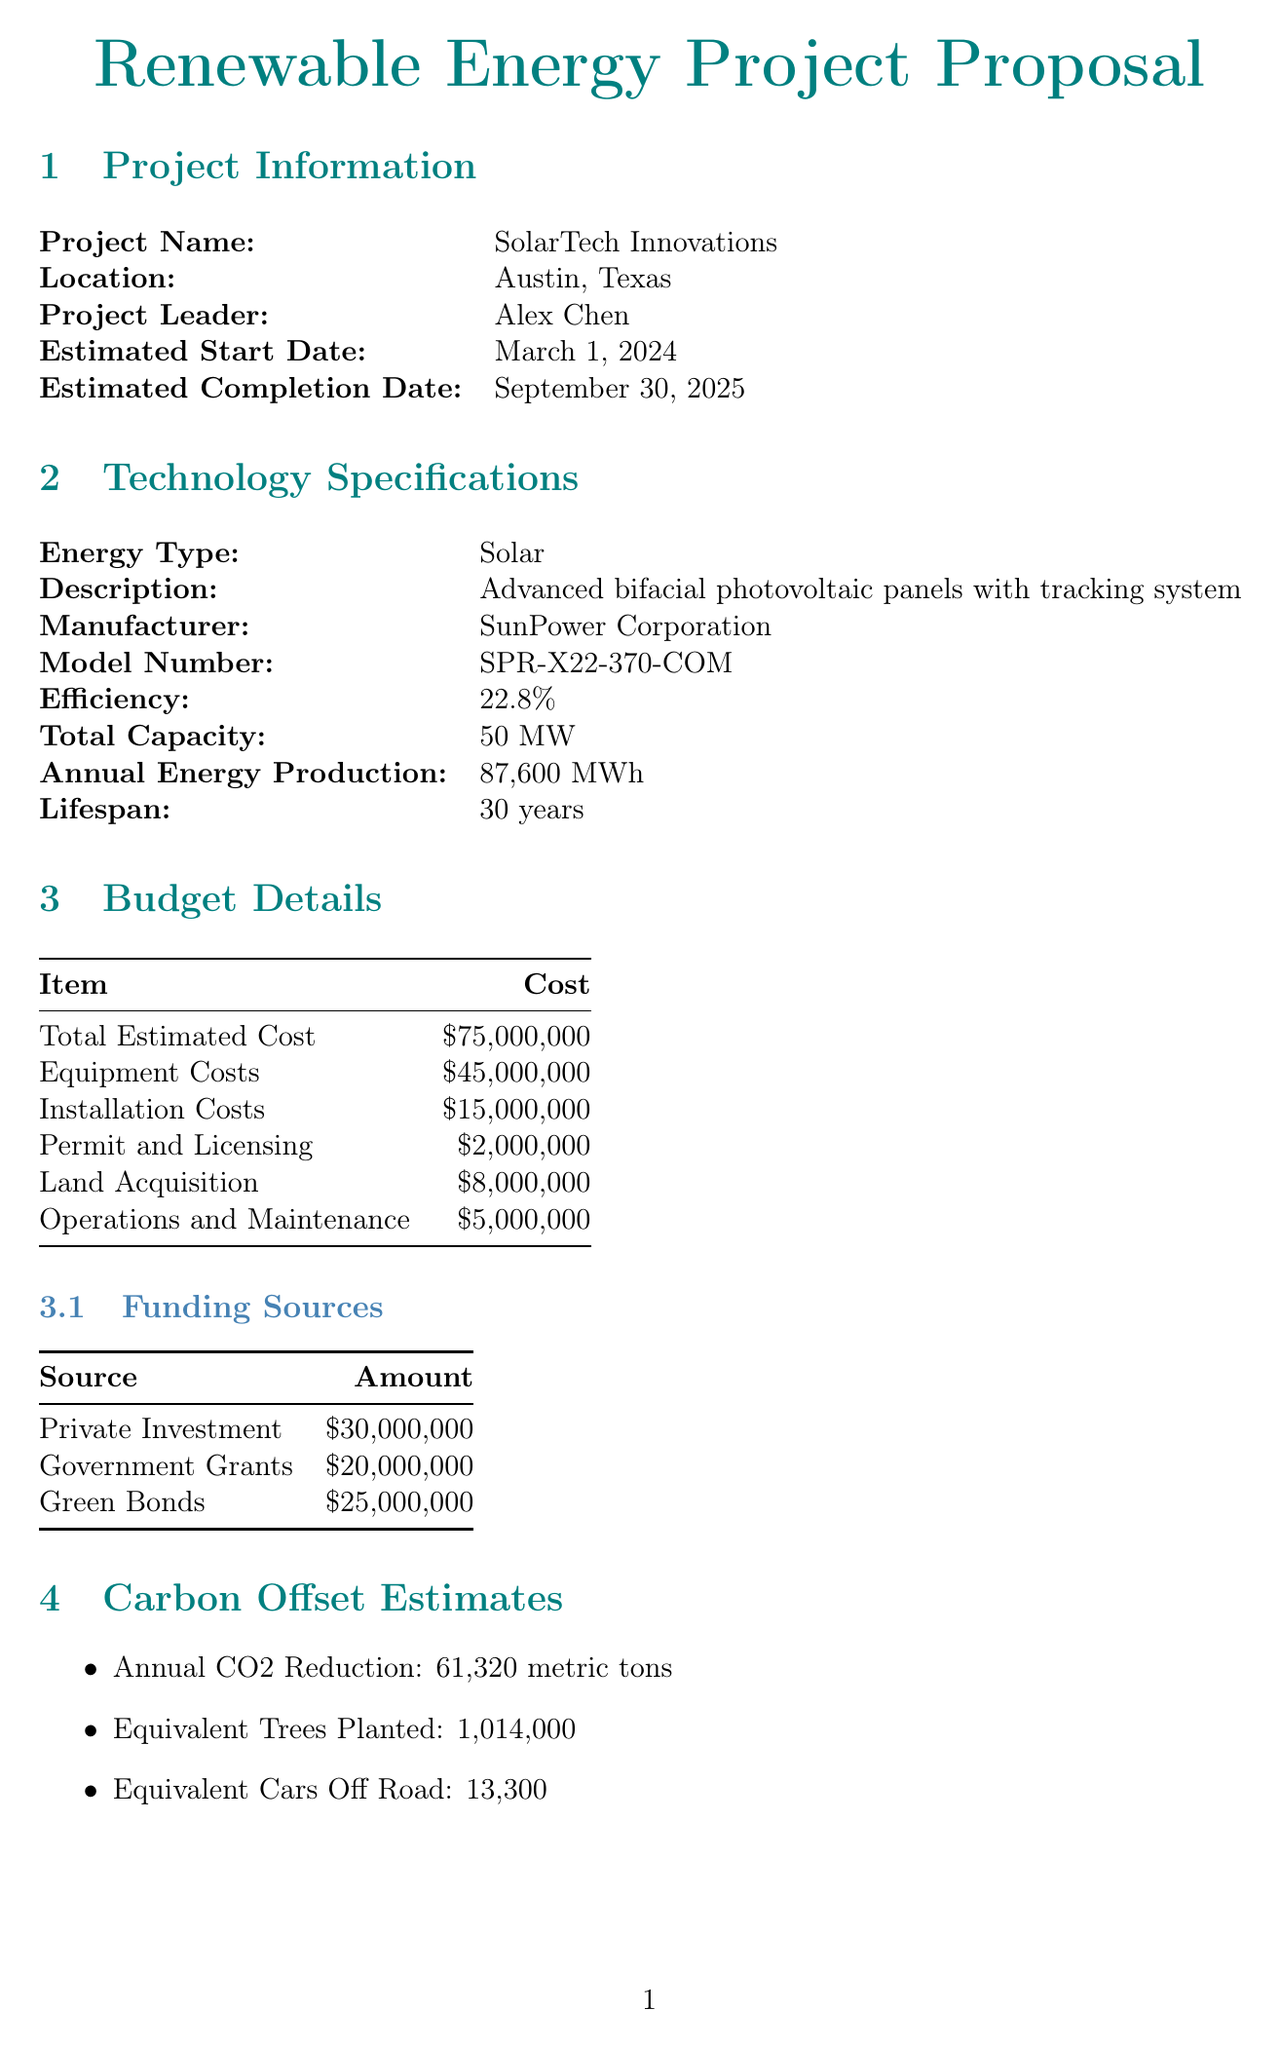What is the project name? The project name is stated in the project information section of the document.
Answer: SolarTech Innovations What is the total capacity of the solar energy project? The total capacity is specified in the technology specifications section of the document.
Answer: 50 MW Who is the project leader? The project leader's name is mentioned in the project information section.
Answer: Alex Chen What is the estimated completion date? The estimated completion date is listed in the project information section of the document.
Answer: September 30, 2025 What is the total estimated cost of the project? The total estimated cost is found in the budget details section of the document.
Answer: $75,000,000 What is the annual CO2 reduction expected from the project? The annual CO2 reduction is listed in the carbon offset estimates section of the document.
Answer: 61,320 metric tons How many jobs will be created during construction? The number of jobs created during construction is specified in the community benefits section.
Answer: 150 What is the expected local economic impact annually? The expected local economic impact is mentioned in the community benefits section.
Answer: $10,000,000 What risks are associated with technology in this project? Technological risks are outlined in the risk assessment section.
Answer: Rapid advancements may lead to obsolescence What is the lifespan of the solar technology being used? The lifespan of the technology is provided in the technology specifications section of the document.
Answer: 30 years 